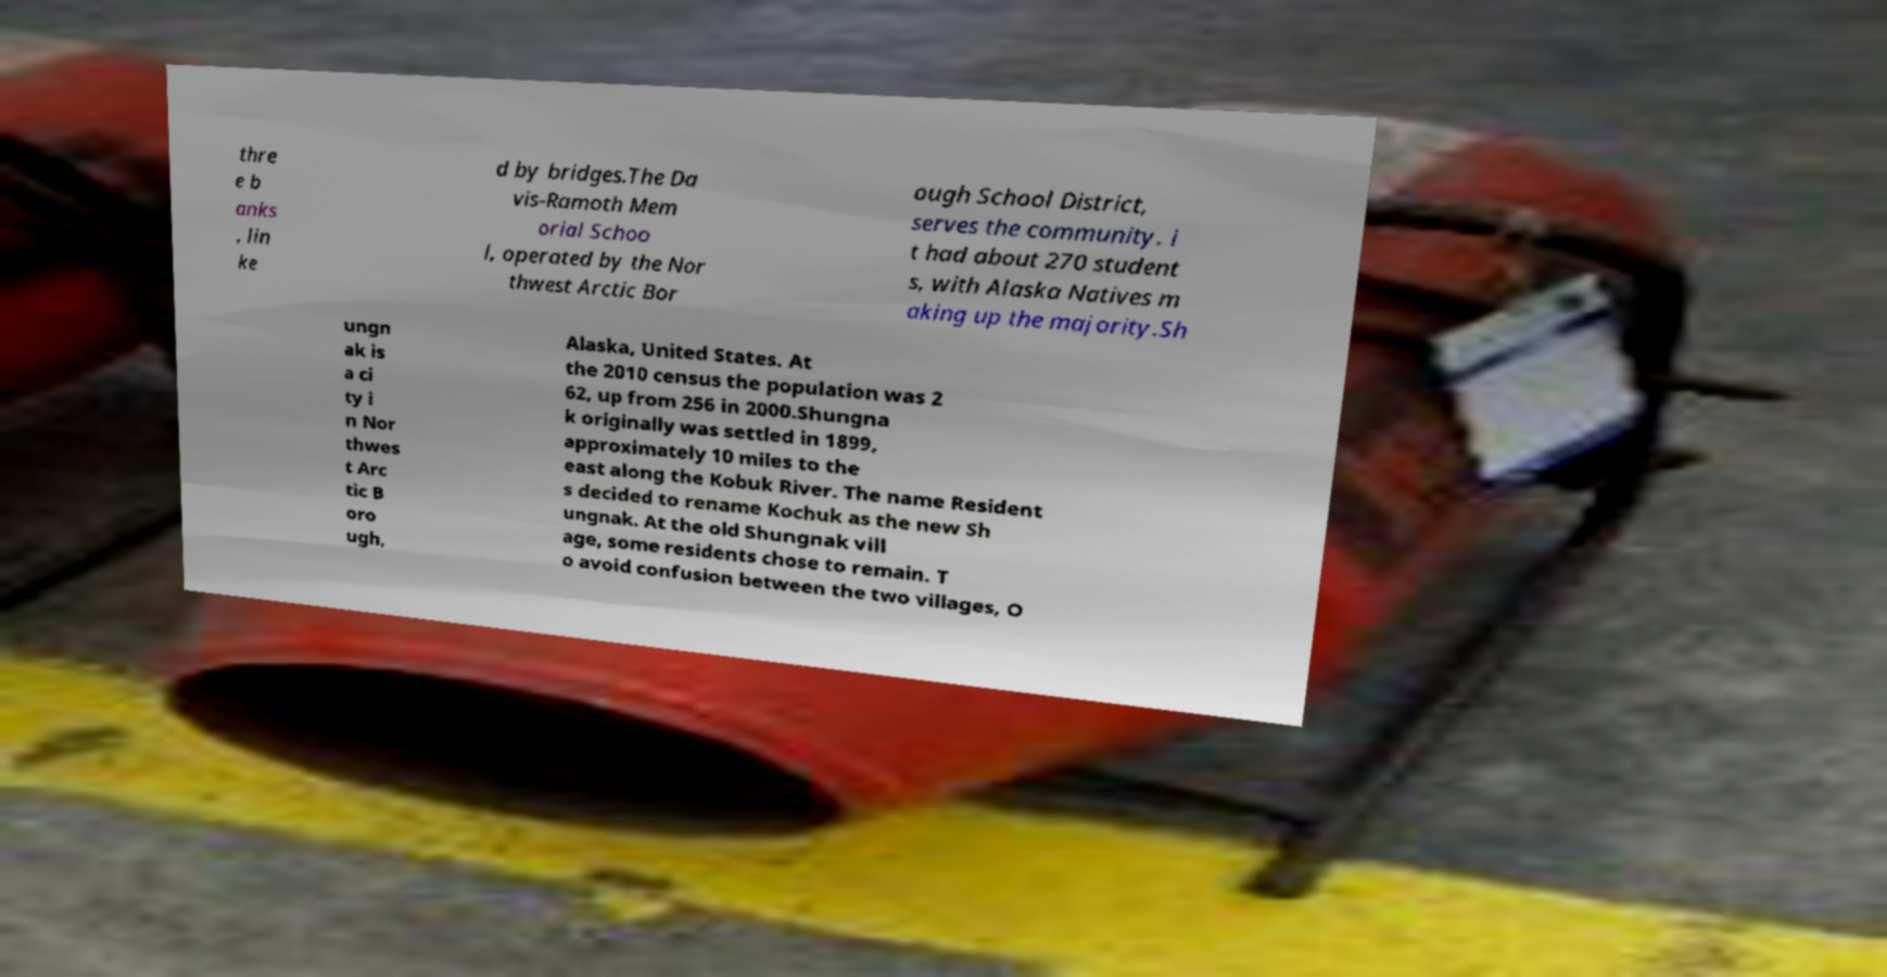For documentation purposes, I need the text within this image transcribed. Could you provide that? thre e b anks , lin ke d by bridges.The Da vis-Ramoth Mem orial Schoo l, operated by the Nor thwest Arctic Bor ough School District, serves the community. i t had about 270 student s, with Alaska Natives m aking up the majority.Sh ungn ak is a ci ty i n Nor thwes t Arc tic B oro ugh, Alaska, United States. At the 2010 census the population was 2 62, up from 256 in 2000.Shungna k originally was settled in 1899, approximately 10 miles to the east along the Kobuk River. The name Resident s decided to rename Kochuk as the new Sh ungnak. At the old Shungnak vill age, some residents chose to remain. T o avoid confusion between the two villages, O 